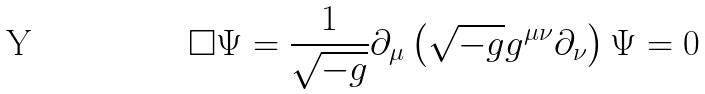<formula> <loc_0><loc_0><loc_500><loc_500>\Box \Psi = \frac { 1 } { \sqrt { - g } } \partial _ { \mu } \left ( \sqrt { - g } g ^ { \mu \nu } \partial _ { \nu } \right ) \Psi = 0</formula> 